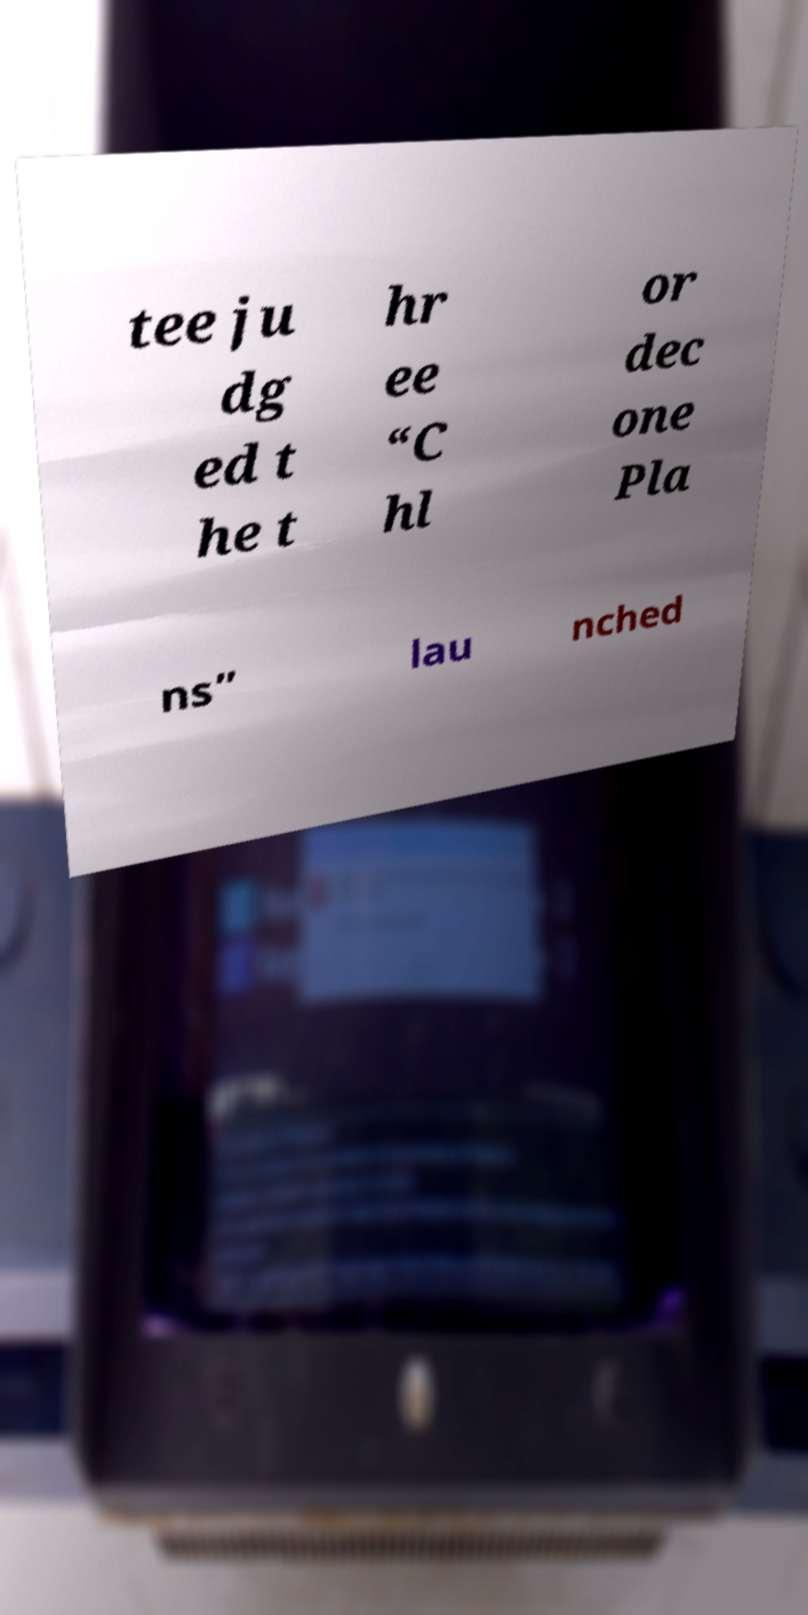Please identify and transcribe the text found in this image. tee ju dg ed t he t hr ee “C hl or dec one Pla ns” lau nched 